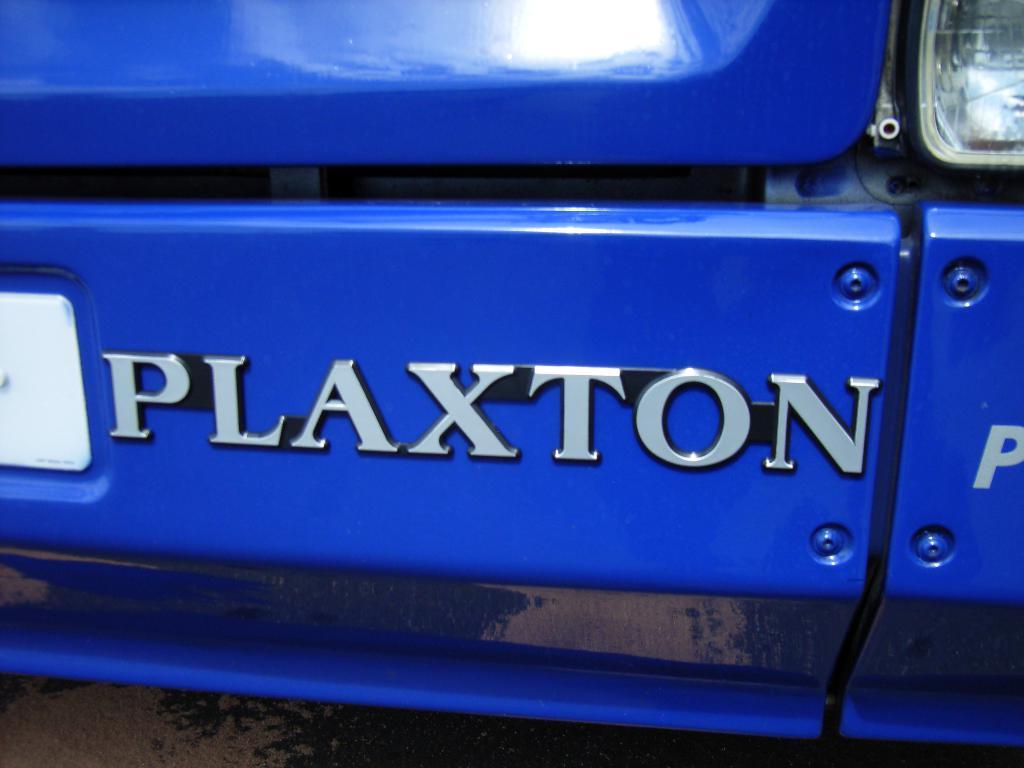In one or two sentences, can you explain what this image depicts? There is a silver color text on a blue color vehicle which is having a light and a white color number plate. This vehicle is on a surface. 